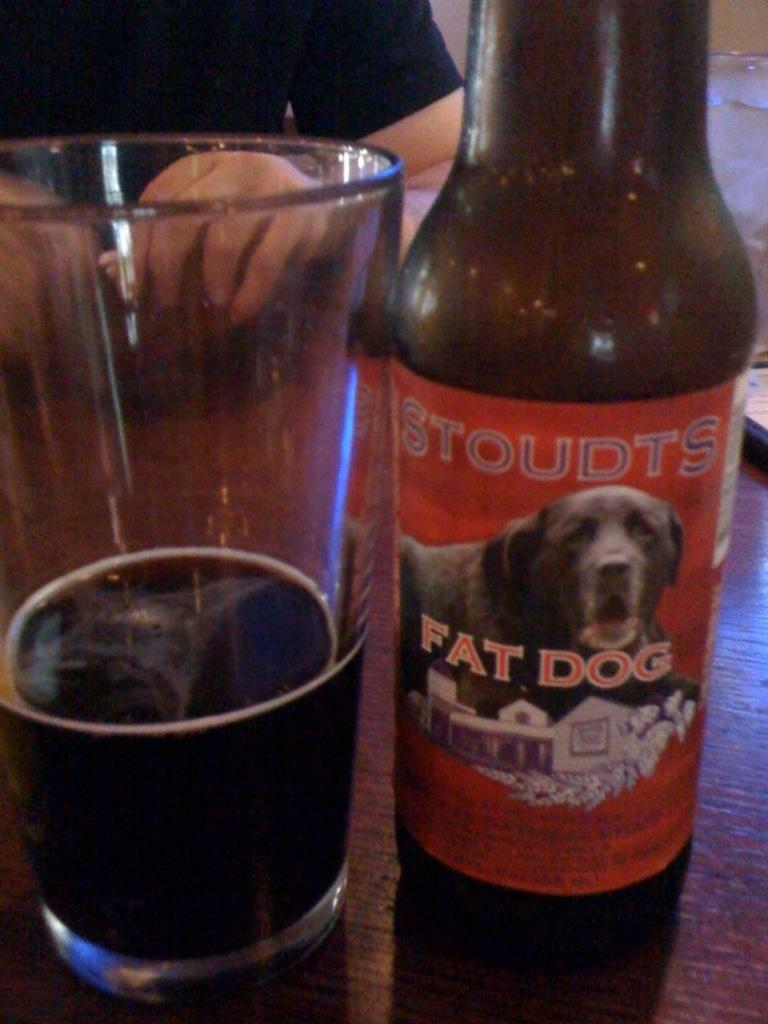Provide a one-sentence caption for the provided image. A bottle of Stoudts Fat Dog sits next to a partially full glass. 